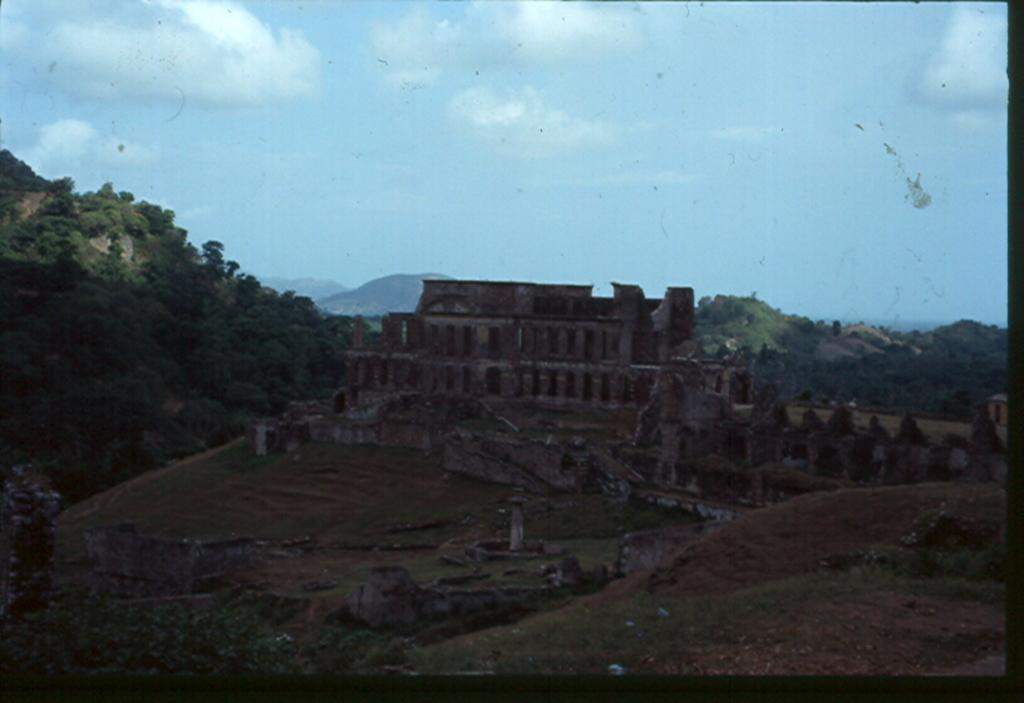What is the main structure in the picture? There is a fort in the picture. What can be seen in the background of the picture? There are trees, hills, and the sky visible in the background of the picture. What type of canvas is being used to paint the fort in the picture? There is no indication in the image that the fort is being painted, nor is there any canvas present. 